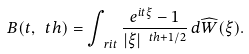<formula> <loc_0><loc_0><loc_500><loc_500>B ( t , \ t h ) = \int _ { \ r i t } \frac { e ^ { i t \xi } - 1 } { | \xi | ^ { \ t h + 1 / 2 } } \, d \widehat { W } ( \xi ) .</formula> 